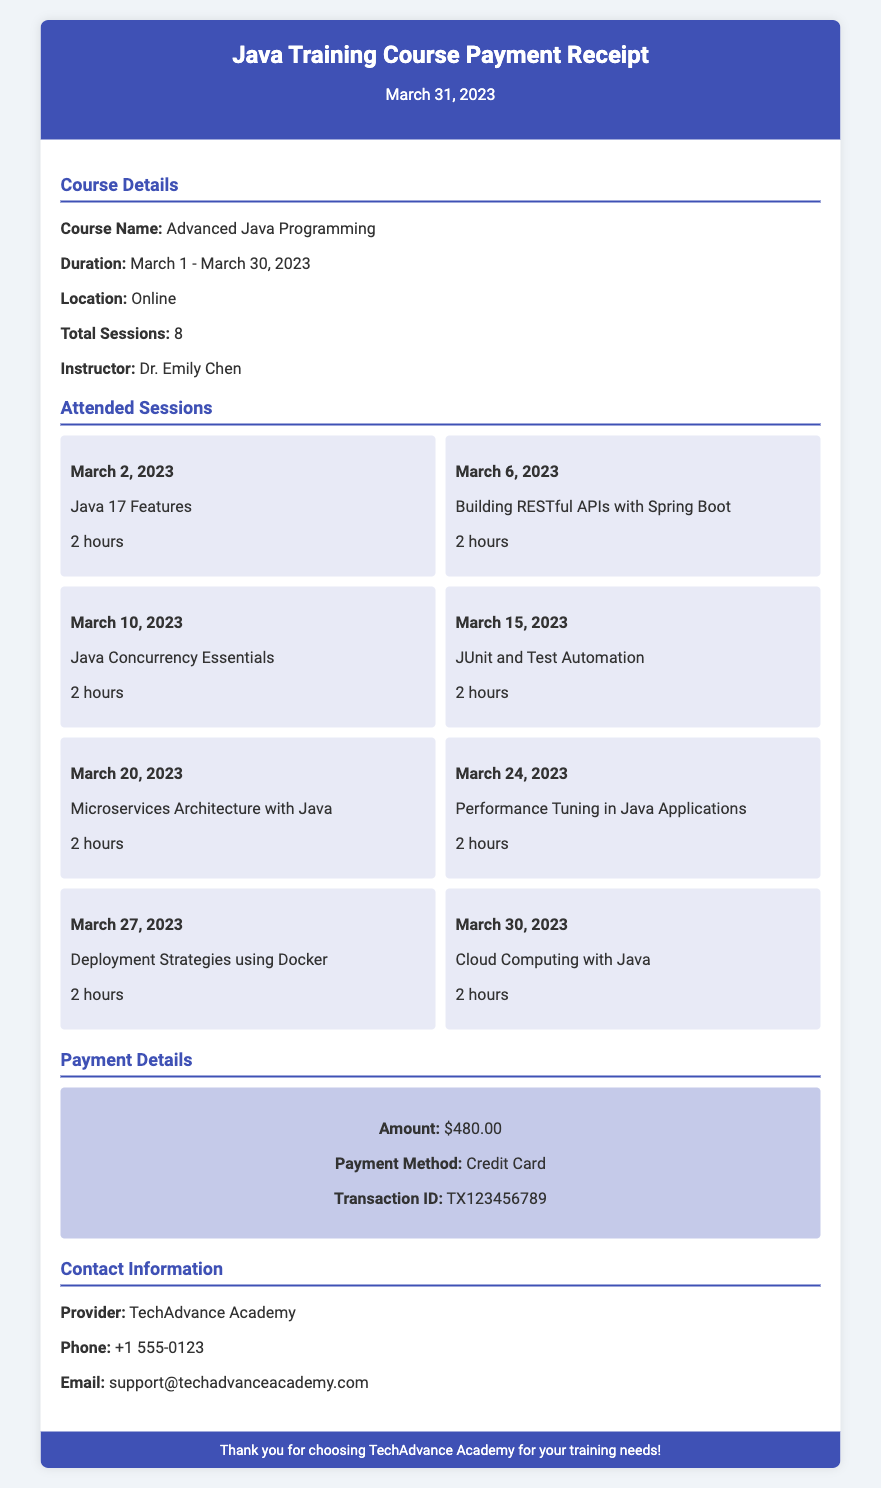What is the course name? The course name is listed in the Course Details section of the document.
Answer: Advanced Java Programming When did the training course start? The starting date of the training course is mentioned in the Course Details section.
Answer: March 1, 2023 How many sessions were attended in total? The total number of sessions attended is detailed in the Course Details section, which mentions the total sessions.
Answer: 8 What was the payment amount? The payment amount can be found in the Payment Details section of the document.
Answer: $480.00 Who is the instructor for the course? The instructor is mentioned in the Course Details section, providing the name of the individual leading the course.
Answer: Dr. Emily Chen What was the last session topic? The last session topic is listed under the Attended Sessions section, showing the final topic of the training.
Answer: Cloud Computing with Java What payment method was used? The payment method used for the transaction is specified in the Payment Details section.
Answer: Credit Card What is the contact email for the provider? The contact email address for the training provider is found in the Contact Information section of the document.
Answer: support@techadvanceacademy.com How many hours did each session last? Each session's duration is uniformly listed in the document, which provides a consistent duration.
Answer: 2 hours 